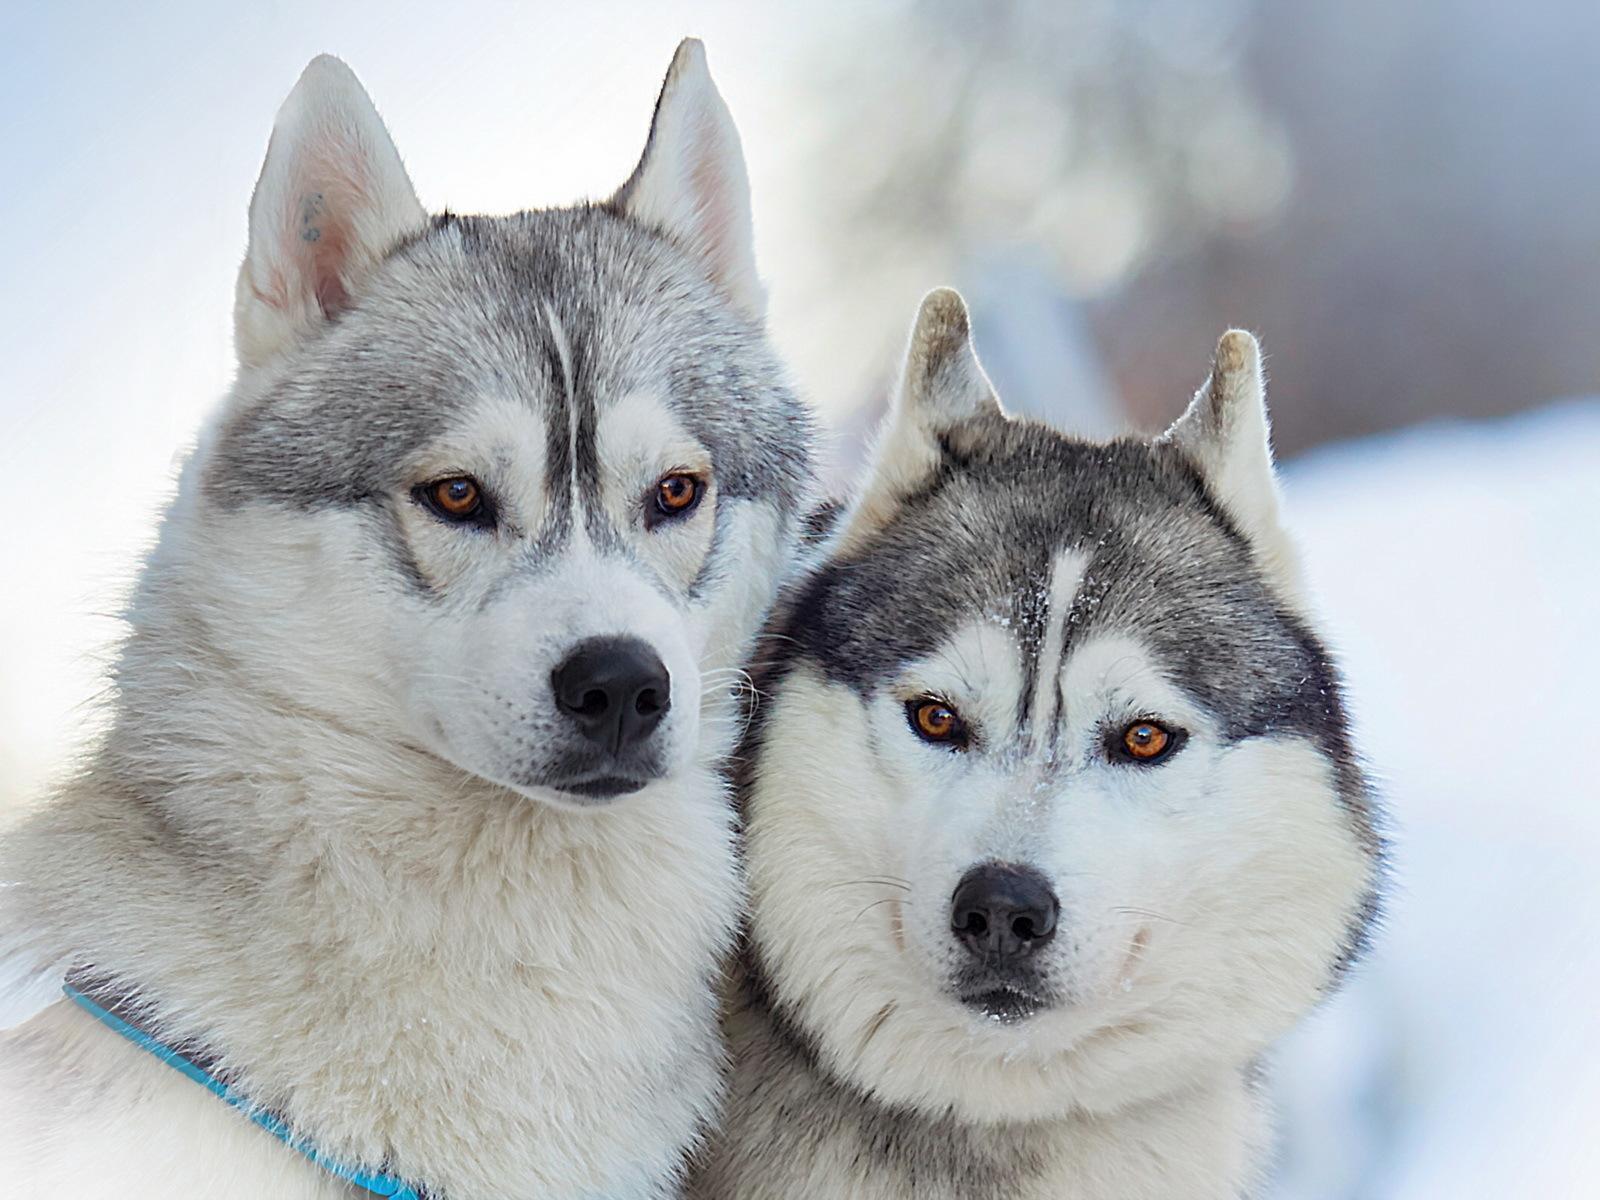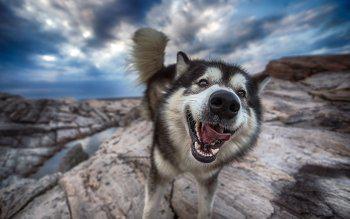The first image is the image on the left, the second image is the image on the right. For the images displayed, is the sentence "There is a dog with its mouth open in each image." factually correct? Answer yes or no. No. The first image is the image on the left, the second image is the image on the right. Analyze the images presented: Is the assertion "One husky has its mouth open but is not snarling, and a different husky wears something blue around itself and has upright ears." valid? Answer yes or no. Yes. 